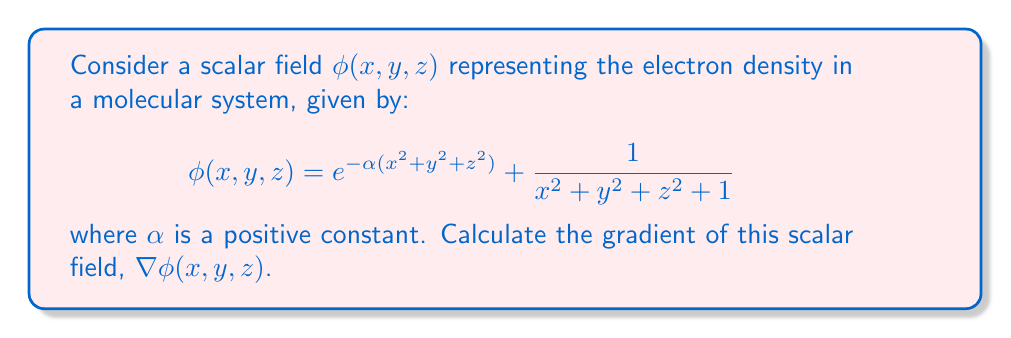Provide a solution to this math problem. To solve this problem, we'll follow these steps:

1) Recall that the gradient of a scalar field $\phi(x, y, z)$ is defined as:

   $$\nabla \phi = \left(\frac{\partial \phi}{\partial x}, \frac{\partial \phi}{\partial y}, \frac{\partial \phi}{\partial z}\right)$$

2) We need to calculate each partial derivative separately.

3) For $\frac{\partial \phi}{\partial x}$:
   $$\begin{align*}
   \frac{\partial \phi}{\partial x} &= \frac{\partial}{\partial x}\left(e^{-\alpha(x^2 + y^2 + z^2)}\right) + \frac{\partial}{\partial x}\left(\frac{1}{x^2 + y^2 + z^2 + 1}\right) \\
   &= e^{-\alpha(x^2 + y^2 + z^2)}(-2\alpha x) + \frac{-2x}{(x^2 + y^2 + z^2 + 1)^2}
   \end{align*}$$

4) For $\frac{\partial \phi}{\partial y}$:
   $$\begin{align*}
   \frac{\partial \phi}{\partial y} &= \frac{\partial}{\partial y}\left(e^{-\alpha(x^2 + y^2 + z^2)}\right) + \frac{\partial}{\partial y}\left(\frac{1}{x^2 + y^2 + z^2 + 1}\right) \\
   &= e^{-\alpha(x^2 + y^2 + z^2)}(-2\alpha y) + \frac{-2y}{(x^2 + y^2 + z^2 + 1)^2}
   \end{align*}$$

5) For $\frac{\partial \phi}{\partial z}$:
   $$\begin{align*}
   \frac{\partial \phi}{\partial z} &= \frac{\partial}{\partial z}\left(e^{-\alpha(x^2 + y^2 + z^2)}\right) + \frac{\partial}{\partial z}\left(\frac{1}{x^2 + y^2 + z^2 + 1}\right) \\
   &= e^{-\alpha(x^2 + y^2 + z^2)}(-2\alpha z) + \frac{-2z}{(x^2 + y^2 + z^2 + 1)^2}
   \end{align*}$$

6) Combining these results into the gradient vector:

   $$\nabla \phi = \left(\frac{\partial \phi}{\partial x}, \frac{\partial \phi}{\partial y}, \frac{\partial \phi}{\partial z}\right)$$
Answer: $$\nabla \phi(x, y, z) = \left(
e^{-\alpha(x^2 + y^2 + z^2)}(-2\alpha x) + \frac{-2x}{(x^2 + y^2 + z^2 + 1)^2},
e^{-\alpha(x^2 + y^2 + z^2)}(-2\alpha y) + \frac{-2y}{(x^2 + y^2 + z^2 + 1)^2},
e^{-\alpha(x^2 + y^2 + z^2)}(-2\alpha z) + \frac{-2z}{(x^2 + y^2 + z^2 + 1)^2}
\right)$$ 